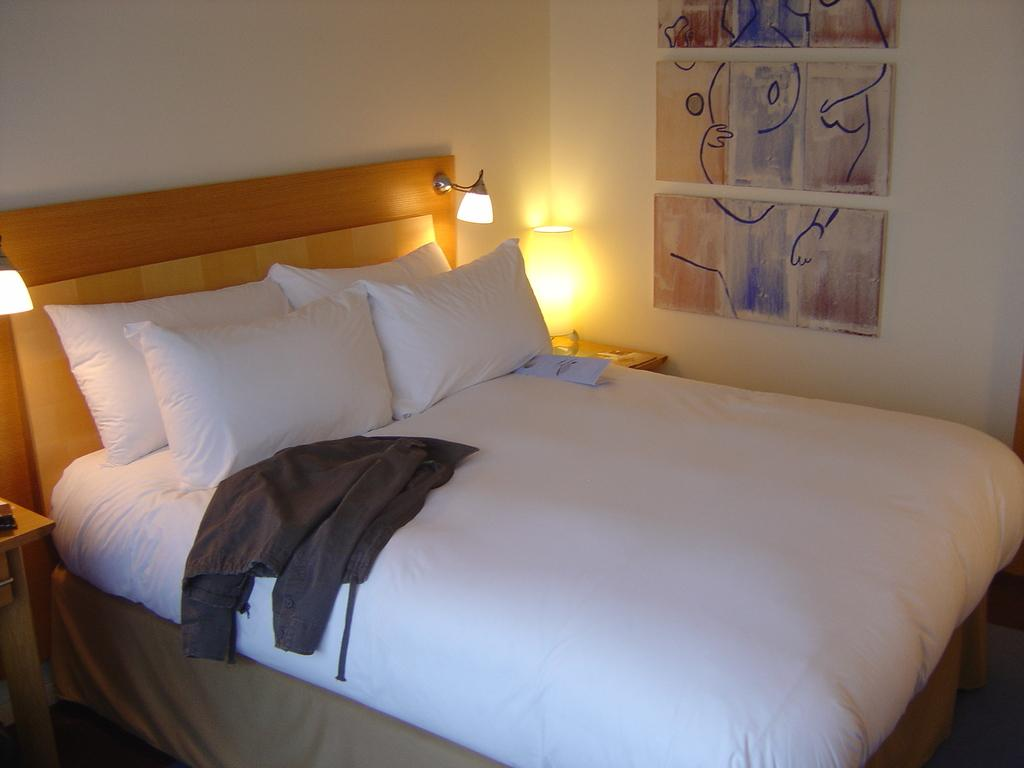What type of furniture is present in the image? There is a bed in the image. What is placed on the bed? There are pillows and a jacket on the bed. What can be seen in the background of the image? There is a wall in the background of the image. What is hanging on the wall? There are frames on the wall. What is visible beneath the bed and wall? There is a floor visible in the image. What type of polish is being applied to the frames on the wall in the image? There is no indication in the image that any polish is being applied to the frames on the wall. What is the current political situation in the image? The image does not depict any political situation or context. 